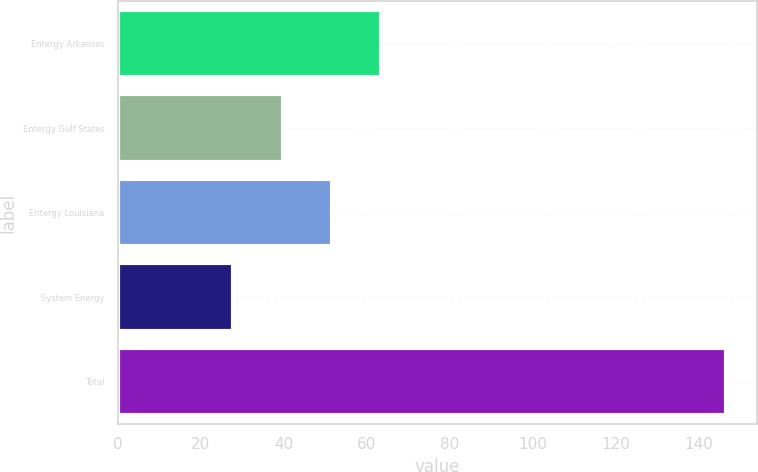Convert chart to OTSL. <chart><loc_0><loc_0><loc_500><loc_500><bar_chart><fcel>Entergy Arkansas<fcel>Entergy Gulf States<fcel>Entergy Louisiana<fcel>System Energy<fcel>Total<nl><fcel>63.44<fcel>39.68<fcel>51.56<fcel>27.8<fcel>146.6<nl></chart> 